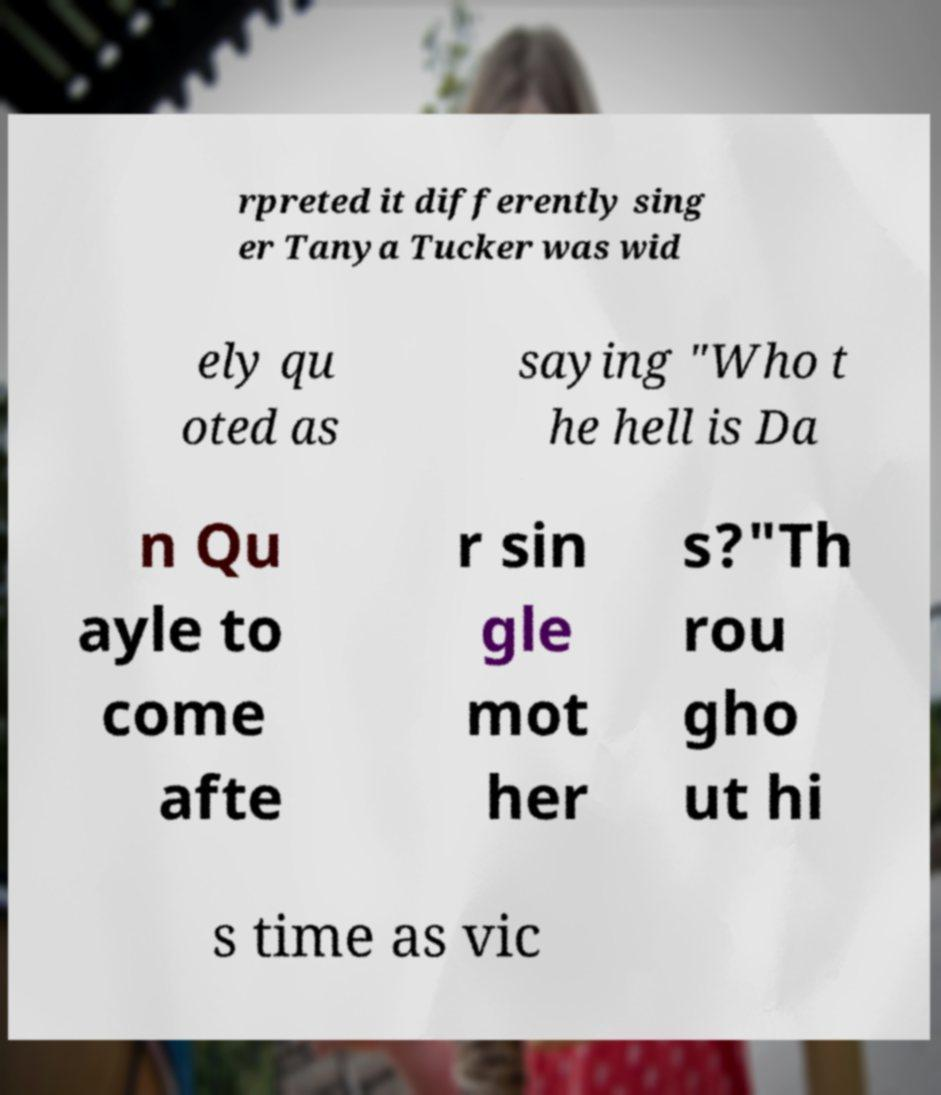Could you extract and type out the text from this image? rpreted it differently sing er Tanya Tucker was wid ely qu oted as saying "Who t he hell is Da n Qu ayle to come afte r sin gle mot her s?"Th rou gho ut hi s time as vic 